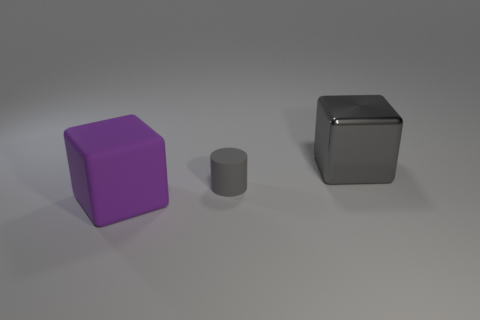There is a rubber object that is the same color as the metallic cube; what shape is it?
Give a very brief answer. Cylinder. There is a big shiny cube; is it the same color as the block left of the small gray rubber cylinder?
Your response must be concise. No. There is another object that is the same material as the purple object; what size is it?
Your answer should be very brief. Small. Do the gray cube and the small gray thing that is behind the large purple block have the same material?
Keep it short and to the point. No. There is another object that is the same color as the small rubber object; what size is it?
Your answer should be compact. Large. Is the shape of the gray metal thing the same as the large object on the left side of the rubber cylinder?
Your answer should be compact. Yes. Is the small rubber cylinder the same color as the big rubber object?
Your answer should be very brief. No. Are there any other things that are the same size as the matte cylinder?
Offer a terse response. No. There is a large object left of the object that is behind the tiny gray object; what is its shape?
Your answer should be compact. Cube. What size is the thing that is both on the right side of the purple thing and in front of the large metallic object?
Make the answer very short. Small. 